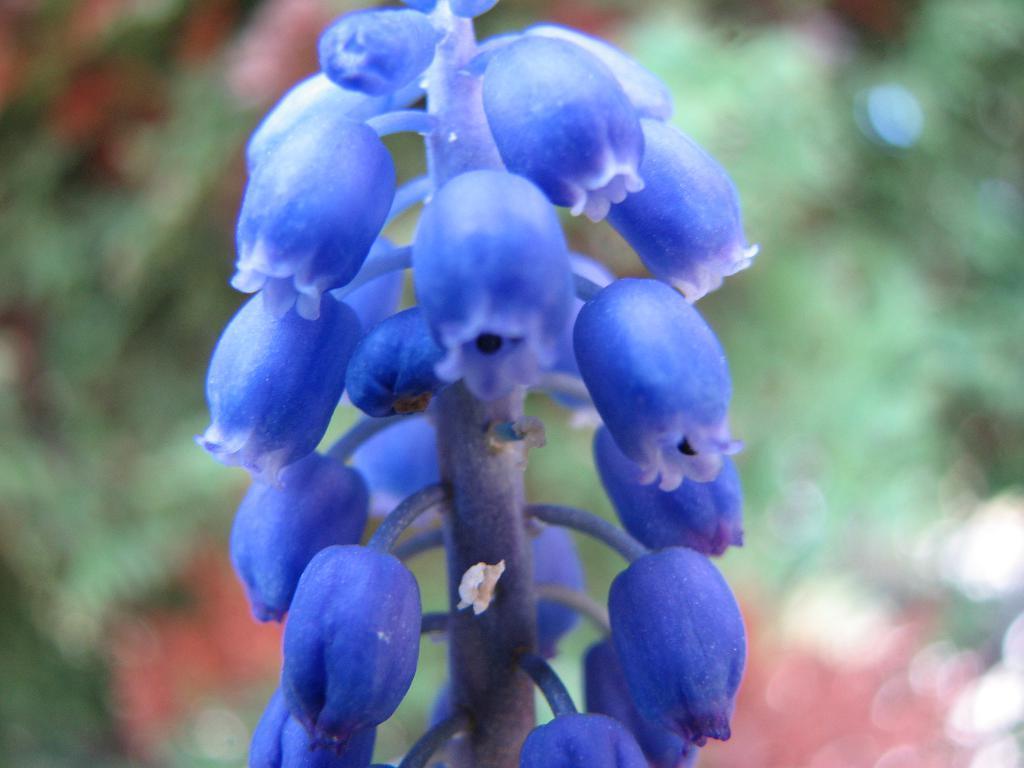Could you give a brief overview of what you see in this image? In this image we can see a stem and flowers. In the background, we can see greenery. 